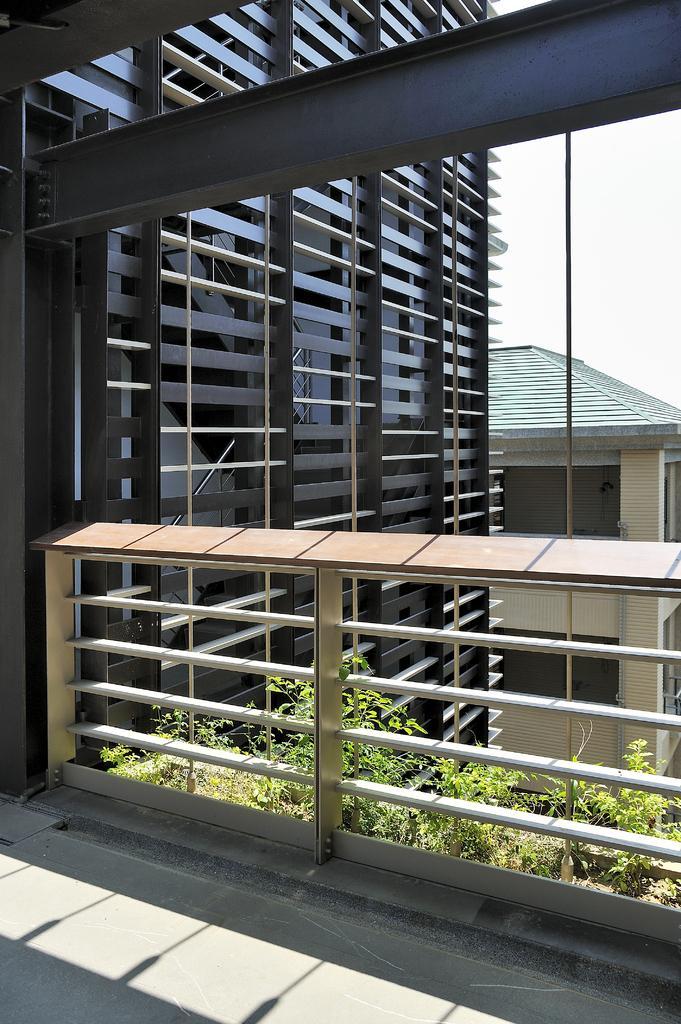Describe this image in one or two sentences. In the foreground I can see a fence, plants and buildings. On the top right I can see the sky. This image is taken during a day. 